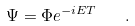Convert formula to latex. <formula><loc_0><loc_0><loc_500><loc_500>\Psi = \Phi e ^ { - i E T } \quad .</formula> 